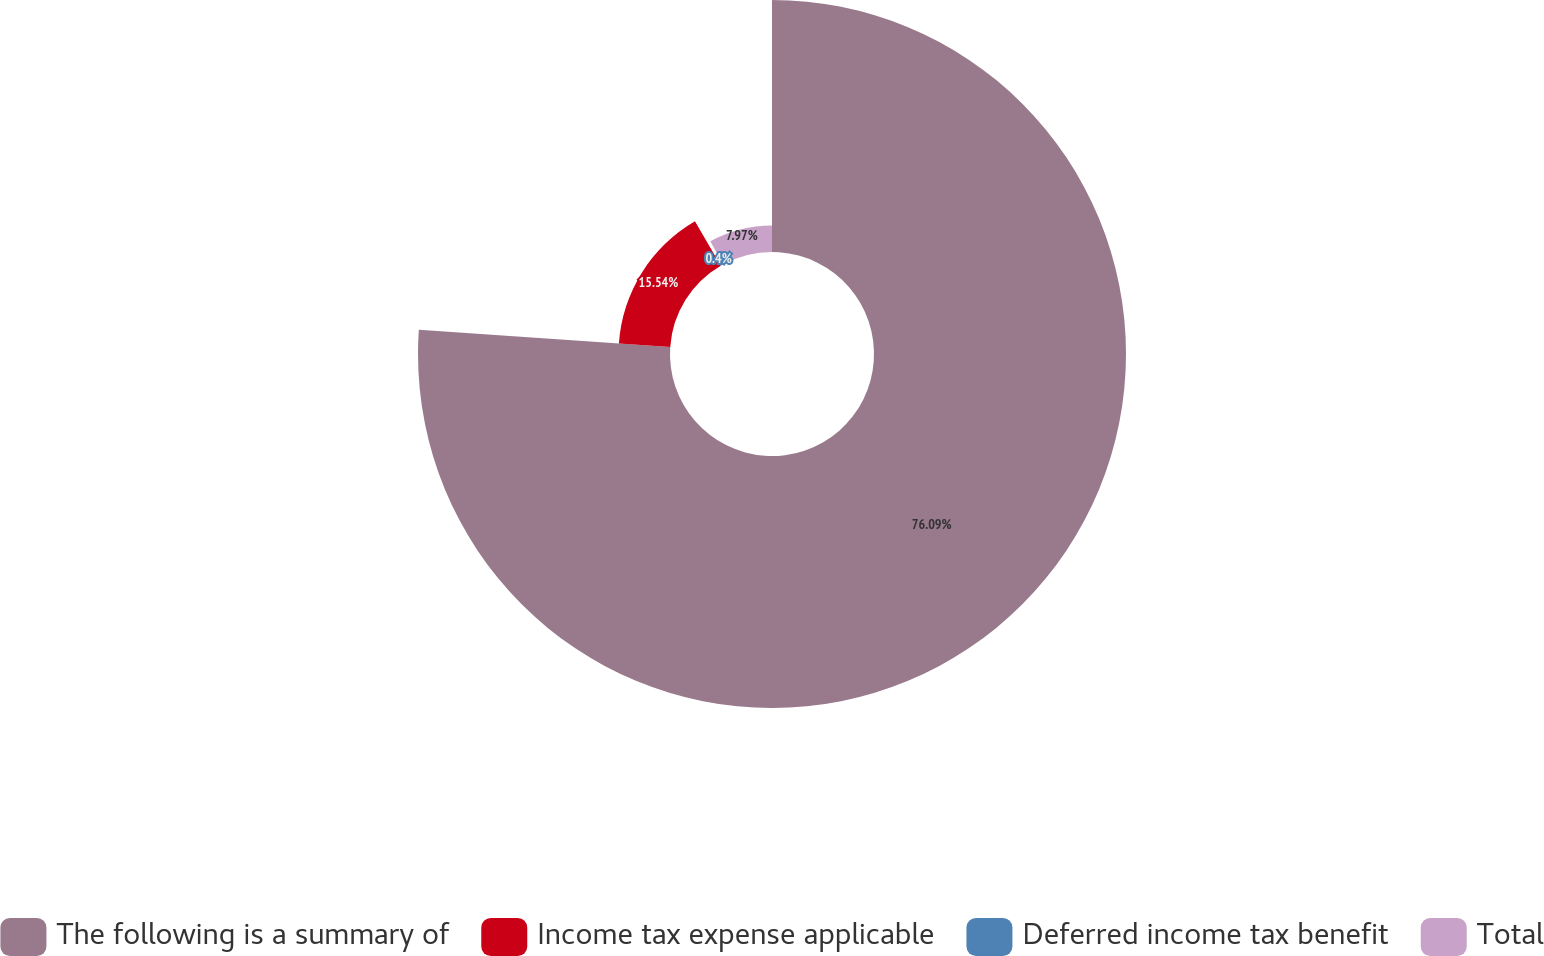Convert chart to OTSL. <chart><loc_0><loc_0><loc_500><loc_500><pie_chart><fcel>The following is a summary of<fcel>Income tax expense applicable<fcel>Deferred income tax benefit<fcel>Total<nl><fcel>76.09%<fcel>15.54%<fcel>0.4%<fcel>7.97%<nl></chart> 